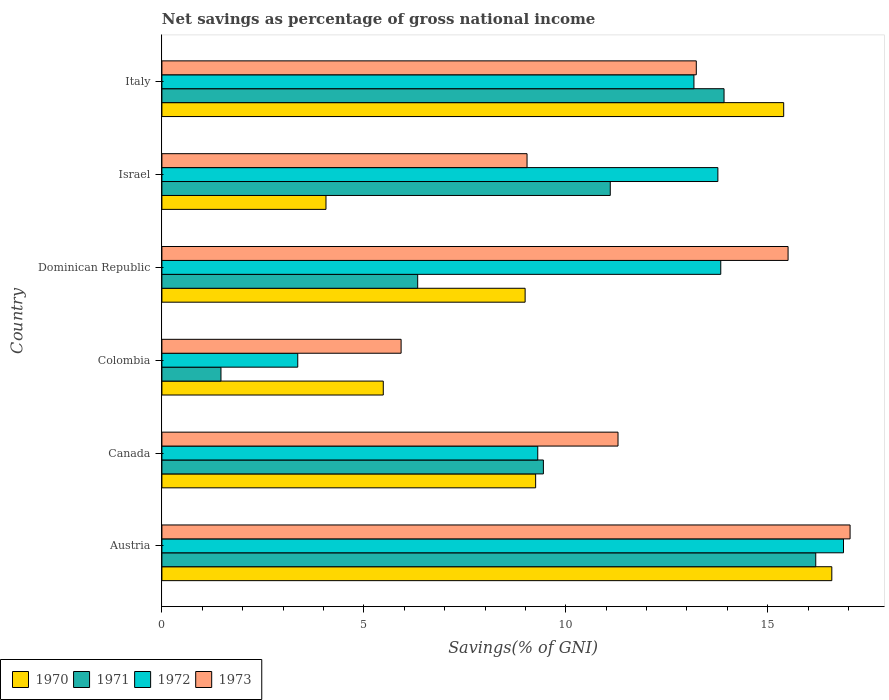Are the number of bars on each tick of the Y-axis equal?
Your response must be concise. Yes. What is the label of the 6th group of bars from the top?
Your response must be concise. Austria. In how many cases, is the number of bars for a given country not equal to the number of legend labels?
Provide a short and direct response. 0. What is the total savings in 1972 in Italy?
Your answer should be compact. 13.17. Across all countries, what is the maximum total savings in 1972?
Your response must be concise. 16.88. Across all countries, what is the minimum total savings in 1972?
Provide a short and direct response. 3.36. In which country was the total savings in 1971 maximum?
Your answer should be very brief. Austria. What is the total total savings in 1971 in the graph?
Provide a short and direct response. 58.45. What is the difference between the total savings in 1971 in Austria and that in Colombia?
Your response must be concise. 14.73. What is the difference between the total savings in 1970 in Austria and the total savings in 1972 in Israel?
Provide a short and direct response. 2.82. What is the average total savings in 1973 per country?
Give a very brief answer. 12.01. What is the difference between the total savings in 1970 and total savings in 1973 in Dominican Republic?
Provide a succinct answer. -6.51. In how many countries, is the total savings in 1970 greater than 7 %?
Your response must be concise. 4. What is the ratio of the total savings in 1973 in Dominican Republic to that in Israel?
Give a very brief answer. 1.71. Is the difference between the total savings in 1970 in Canada and Israel greater than the difference between the total savings in 1973 in Canada and Israel?
Your response must be concise. Yes. What is the difference between the highest and the second highest total savings in 1973?
Make the answer very short. 1.54. What is the difference between the highest and the lowest total savings in 1971?
Keep it short and to the point. 14.73. Is the sum of the total savings in 1970 in Canada and Dominican Republic greater than the maximum total savings in 1971 across all countries?
Your answer should be very brief. Yes. Is it the case that in every country, the sum of the total savings in 1973 and total savings in 1971 is greater than the sum of total savings in 1972 and total savings in 1970?
Your answer should be very brief. No. What does the 2nd bar from the bottom in Italy represents?
Give a very brief answer. 1971. How many bars are there?
Keep it short and to the point. 24. Are all the bars in the graph horizontal?
Provide a short and direct response. Yes. Does the graph contain grids?
Your answer should be very brief. No. Where does the legend appear in the graph?
Ensure brevity in your answer.  Bottom left. How are the legend labels stacked?
Provide a succinct answer. Horizontal. What is the title of the graph?
Your response must be concise. Net savings as percentage of gross national income. What is the label or title of the X-axis?
Keep it short and to the point. Savings(% of GNI). What is the Savings(% of GNI) of 1970 in Austria?
Provide a short and direct response. 16.59. What is the Savings(% of GNI) of 1971 in Austria?
Your answer should be compact. 16.19. What is the Savings(% of GNI) in 1972 in Austria?
Provide a short and direct response. 16.88. What is the Savings(% of GNI) of 1973 in Austria?
Make the answer very short. 17.04. What is the Savings(% of GNI) of 1970 in Canada?
Your response must be concise. 9.25. What is the Savings(% of GNI) in 1971 in Canada?
Give a very brief answer. 9.45. What is the Savings(% of GNI) in 1972 in Canada?
Your answer should be compact. 9.31. What is the Savings(% of GNI) of 1973 in Canada?
Offer a terse response. 11.29. What is the Savings(% of GNI) of 1970 in Colombia?
Your answer should be very brief. 5.48. What is the Savings(% of GNI) in 1971 in Colombia?
Offer a very short reply. 1.46. What is the Savings(% of GNI) of 1972 in Colombia?
Make the answer very short. 3.36. What is the Savings(% of GNI) of 1973 in Colombia?
Your response must be concise. 5.92. What is the Savings(% of GNI) in 1970 in Dominican Republic?
Provide a short and direct response. 8.99. What is the Savings(% of GNI) of 1971 in Dominican Republic?
Give a very brief answer. 6.33. What is the Savings(% of GNI) in 1972 in Dominican Republic?
Keep it short and to the point. 13.84. What is the Savings(% of GNI) in 1973 in Dominican Republic?
Your answer should be compact. 15.5. What is the Savings(% of GNI) of 1970 in Israel?
Keep it short and to the point. 4.06. What is the Savings(% of GNI) of 1971 in Israel?
Provide a short and direct response. 11.1. What is the Savings(% of GNI) in 1972 in Israel?
Offer a terse response. 13.77. What is the Savings(% of GNI) of 1973 in Israel?
Offer a very short reply. 9.04. What is the Savings(% of GNI) of 1970 in Italy?
Your answer should be very brief. 15.4. What is the Savings(% of GNI) of 1971 in Italy?
Make the answer very short. 13.92. What is the Savings(% of GNI) of 1972 in Italy?
Your response must be concise. 13.17. What is the Savings(% of GNI) of 1973 in Italy?
Ensure brevity in your answer.  13.23. Across all countries, what is the maximum Savings(% of GNI) of 1970?
Ensure brevity in your answer.  16.59. Across all countries, what is the maximum Savings(% of GNI) of 1971?
Your answer should be very brief. 16.19. Across all countries, what is the maximum Savings(% of GNI) of 1972?
Provide a succinct answer. 16.88. Across all countries, what is the maximum Savings(% of GNI) of 1973?
Your response must be concise. 17.04. Across all countries, what is the minimum Savings(% of GNI) in 1970?
Ensure brevity in your answer.  4.06. Across all countries, what is the minimum Savings(% of GNI) of 1971?
Keep it short and to the point. 1.46. Across all countries, what is the minimum Savings(% of GNI) of 1972?
Your answer should be very brief. 3.36. Across all countries, what is the minimum Savings(% of GNI) in 1973?
Provide a succinct answer. 5.92. What is the total Savings(% of GNI) in 1970 in the graph?
Offer a very short reply. 59.78. What is the total Savings(% of GNI) of 1971 in the graph?
Make the answer very short. 58.45. What is the total Savings(% of GNI) of 1972 in the graph?
Make the answer very short. 70.32. What is the total Savings(% of GNI) in 1973 in the graph?
Offer a terse response. 72.03. What is the difference between the Savings(% of GNI) in 1970 in Austria and that in Canada?
Make the answer very short. 7.33. What is the difference between the Savings(% of GNI) of 1971 in Austria and that in Canada?
Offer a very short reply. 6.74. What is the difference between the Savings(% of GNI) of 1972 in Austria and that in Canada?
Ensure brevity in your answer.  7.57. What is the difference between the Savings(% of GNI) of 1973 in Austria and that in Canada?
Offer a terse response. 5.75. What is the difference between the Savings(% of GNI) in 1970 in Austria and that in Colombia?
Keep it short and to the point. 11.11. What is the difference between the Savings(% of GNI) in 1971 in Austria and that in Colombia?
Your response must be concise. 14.73. What is the difference between the Savings(% of GNI) in 1972 in Austria and that in Colombia?
Ensure brevity in your answer.  13.51. What is the difference between the Savings(% of GNI) of 1973 in Austria and that in Colombia?
Make the answer very short. 11.12. What is the difference between the Savings(% of GNI) of 1970 in Austria and that in Dominican Republic?
Your answer should be compact. 7.59. What is the difference between the Savings(% of GNI) in 1971 in Austria and that in Dominican Republic?
Provide a short and direct response. 9.86. What is the difference between the Savings(% of GNI) of 1972 in Austria and that in Dominican Republic?
Your answer should be compact. 3.04. What is the difference between the Savings(% of GNI) in 1973 in Austria and that in Dominican Republic?
Provide a short and direct response. 1.54. What is the difference between the Savings(% of GNI) in 1970 in Austria and that in Israel?
Offer a terse response. 12.52. What is the difference between the Savings(% of GNI) in 1971 in Austria and that in Israel?
Your answer should be compact. 5.09. What is the difference between the Savings(% of GNI) of 1972 in Austria and that in Israel?
Your response must be concise. 3.11. What is the difference between the Savings(% of GNI) in 1973 in Austria and that in Israel?
Your answer should be compact. 8. What is the difference between the Savings(% of GNI) of 1970 in Austria and that in Italy?
Give a very brief answer. 1.19. What is the difference between the Savings(% of GNI) of 1971 in Austria and that in Italy?
Your answer should be very brief. 2.27. What is the difference between the Savings(% of GNI) in 1972 in Austria and that in Italy?
Keep it short and to the point. 3.7. What is the difference between the Savings(% of GNI) in 1973 in Austria and that in Italy?
Your response must be concise. 3.81. What is the difference between the Savings(% of GNI) in 1970 in Canada and that in Colombia?
Ensure brevity in your answer.  3.77. What is the difference between the Savings(% of GNI) of 1971 in Canada and that in Colombia?
Offer a very short reply. 7.98. What is the difference between the Savings(% of GNI) in 1972 in Canada and that in Colombia?
Your response must be concise. 5.94. What is the difference between the Savings(% of GNI) of 1973 in Canada and that in Colombia?
Ensure brevity in your answer.  5.37. What is the difference between the Savings(% of GNI) in 1970 in Canada and that in Dominican Republic?
Keep it short and to the point. 0.26. What is the difference between the Savings(% of GNI) in 1971 in Canada and that in Dominican Republic?
Provide a short and direct response. 3.11. What is the difference between the Savings(% of GNI) of 1972 in Canada and that in Dominican Republic?
Provide a succinct answer. -4.53. What is the difference between the Savings(% of GNI) of 1973 in Canada and that in Dominican Republic?
Give a very brief answer. -4.21. What is the difference between the Savings(% of GNI) of 1970 in Canada and that in Israel?
Offer a very short reply. 5.19. What is the difference between the Savings(% of GNI) in 1971 in Canada and that in Israel?
Your answer should be compact. -1.66. What is the difference between the Savings(% of GNI) of 1972 in Canada and that in Israel?
Offer a very short reply. -4.46. What is the difference between the Savings(% of GNI) of 1973 in Canada and that in Israel?
Your answer should be very brief. 2.25. What is the difference between the Savings(% of GNI) in 1970 in Canada and that in Italy?
Your response must be concise. -6.14. What is the difference between the Savings(% of GNI) in 1971 in Canada and that in Italy?
Your response must be concise. -4.47. What is the difference between the Savings(% of GNI) in 1972 in Canada and that in Italy?
Your answer should be very brief. -3.87. What is the difference between the Savings(% of GNI) in 1973 in Canada and that in Italy?
Your response must be concise. -1.94. What is the difference between the Savings(% of GNI) in 1970 in Colombia and that in Dominican Republic?
Make the answer very short. -3.51. What is the difference between the Savings(% of GNI) of 1971 in Colombia and that in Dominican Republic?
Give a very brief answer. -4.87. What is the difference between the Savings(% of GNI) in 1972 in Colombia and that in Dominican Republic?
Keep it short and to the point. -10.47. What is the difference between the Savings(% of GNI) of 1973 in Colombia and that in Dominican Republic?
Your response must be concise. -9.58. What is the difference between the Savings(% of GNI) of 1970 in Colombia and that in Israel?
Provide a short and direct response. 1.42. What is the difference between the Savings(% of GNI) of 1971 in Colombia and that in Israel?
Offer a terse response. -9.64. What is the difference between the Savings(% of GNI) of 1972 in Colombia and that in Israel?
Give a very brief answer. -10.4. What is the difference between the Savings(% of GNI) of 1973 in Colombia and that in Israel?
Give a very brief answer. -3.12. What is the difference between the Savings(% of GNI) in 1970 in Colombia and that in Italy?
Provide a succinct answer. -9.91. What is the difference between the Savings(% of GNI) of 1971 in Colombia and that in Italy?
Your response must be concise. -12.46. What is the difference between the Savings(% of GNI) of 1972 in Colombia and that in Italy?
Offer a very short reply. -9.81. What is the difference between the Savings(% of GNI) of 1973 in Colombia and that in Italy?
Provide a short and direct response. -7.31. What is the difference between the Savings(% of GNI) of 1970 in Dominican Republic and that in Israel?
Provide a succinct answer. 4.93. What is the difference between the Savings(% of GNI) of 1971 in Dominican Republic and that in Israel?
Offer a terse response. -4.77. What is the difference between the Savings(% of GNI) of 1972 in Dominican Republic and that in Israel?
Your response must be concise. 0.07. What is the difference between the Savings(% of GNI) of 1973 in Dominican Republic and that in Israel?
Your response must be concise. 6.46. What is the difference between the Savings(% of GNI) of 1970 in Dominican Republic and that in Italy?
Offer a terse response. -6.4. What is the difference between the Savings(% of GNI) in 1971 in Dominican Republic and that in Italy?
Offer a very short reply. -7.59. What is the difference between the Savings(% of GNI) in 1972 in Dominican Republic and that in Italy?
Your answer should be very brief. 0.66. What is the difference between the Savings(% of GNI) in 1973 in Dominican Republic and that in Italy?
Give a very brief answer. 2.27. What is the difference between the Savings(% of GNI) of 1970 in Israel and that in Italy?
Your answer should be very brief. -11.33. What is the difference between the Savings(% of GNI) in 1971 in Israel and that in Italy?
Offer a terse response. -2.82. What is the difference between the Savings(% of GNI) of 1972 in Israel and that in Italy?
Provide a short and direct response. 0.59. What is the difference between the Savings(% of GNI) of 1973 in Israel and that in Italy?
Provide a short and direct response. -4.19. What is the difference between the Savings(% of GNI) of 1970 in Austria and the Savings(% of GNI) of 1971 in Canada?
Provide a short and direct response. 7.14. What is the difference between the Savings(% of GNI) in 1970 in Austria and the Savings(% of GNI) in 1972 in Canada?
Your answer should be compact. 7.28. What is the difference between the Savings(% of GNI) in 1970 in Austria and the Savings(% of GNI) in 1973 in Canada?
Offer a very short reply. 5.29. What is the difference between the Savings(% of GNI) of 1971 in Austria and the Savings(% of GNI) of 1972 in Canada?
Provide a succinct answer. 6.88. What is the difference between the Savings(% of GNI) of 1971 in Austria and the Savings(% of GNI) of 1973 in Canada?
Your answer should be very brief. 4.9. What is the difference between the Savings(% of GNI) of 1972 in Austria and the Savings(% of GNI) of 1973 in Canada?
Your answer should be compact. 5.58. What is the difference between the Savings(% of GNI) of 1970 in Austria and the Savings(% of GNI) of 1971 in Colombia?
Your answer should be compact. 15.12. What is the difference between the Savings(% of GNI) of 1970 in Austria and the Savings(% of GNI) of 1972 in Colombia?
Your answer should be compact. 13.22. What is the difference between the Savings(% of GNI) of 1970 in Austria and the Savings(% of GNI) of 1973 in Colombia?
Offer a terse response. 10.66. What is the difference between the Savings(% of GNI) of 1971 in Austria and the Savings(% of GNI) of 1972 in Colombia?
Your answer should be compact. 12.83. What is the difference between the Savings(% of GNI) in 1971 in Austria and the Savings(% of GNI) in 1973 in Colombia?
Keep it short and to the point. 10.27. What is the difference between the Savings(% of GNI) of 1972 in Austria and the Savings(% of GNI) of 1973 in Colombia?
Give a very brief answer. 10.95. What is the difference between the Savings(% of GNI) in 1970 in Austria and the Savings(% of GNI) in 1971 in Dominican Republic?
Keep it short and to the point. 10.25. What is the difference between the Savings(% of GNI) of 1970 in Austria and the Savings(% of GNI) of 1972 in Dominican Republic?
Offer a terse response. 2.75. What is the difference between the Savings(% of GNI) in 1970 in Austria and the Savings(% of GNI) in 1973 in Dominican Republic?
Provide a succinct answer. 1.08. What is the difference between the Savings(% of GNI) of 1971 in Austria and the Savings(% of GNI) of 1972 in Dominican Republic?
Your answer should be very brief. 2.35. What is the difference between the Savings(% of GNI) of 1971 in Austria and the Savings(% of GNI) of 1973 in Dominican Republic?
Provide a short and direct response. 0.69. What is the difference between the Savings(% of GNI) of 1972 in Austria and the Savings(% of GNI) of 1973 in Dominican Republic?
Your answer should be very brief. 1.37. What is the difference between the Savings(% of GNI) in 1970 in Austria and the Savings(% of GNI) in 1971 in Israel?
Offer a terse response. 5.49. What is the difference between the Savings(% of GNI) in 1970 in Austria and the Savings(% of GNI) in 1972 in Israel?
Offer a terse response. 2.82. What is the difference between the Savings(% of GNI) in 1970 in Austria and the Savings(% of GNI) in 1973 in Israel?
Your response must be concise. 7.55. What is the difference between the Savings(% of GNI) of 1971 in Austria and the Savings(% of GNI) of 1972 in Israel?
Your answer should be compact. 2.42. What is the difference between the Savings(% of GNI) of 1971 in Austria and the Savings(% of GNI) of 1973 in Israel?
Offer a terse response. 7.15. What is the difference between the Savings(% of GNI) in 1972 in Austria and the Savings(% of GNI) in 1973 in Israel?
Ensure brevity in your answer.  7.84. What is the difference between the Savings(% of GNI) of 1970 in Austria and the Savings(% of GNI) of 1971 in Italy?
Provide a short and direct response. 2.67. What is the difference between the Savings(% of GNI) of 1970 in Austria and the Savings(% of GNI) of 1972 in Italy?
Your answer should be compact. 3.41. What is the difference between the Savings(% of GNI) in 1970 in Austria and the Savings(% of GNI) in 1973 in Italy?
Make the answer very short. 3.36. What is the difference between the Savings(% of GNI) in 1971 in Austria and the Savings(% of GNI) in 1972 in Italy?
Give a very brief answer. 3.02. What is the difference between the Savings(% of GNI) of 1971 in Austria and the Savings(% of GNI) of 1973 in Italy?
Offer a very short reply. 2.96. What is the difference between the Savings(% of GNI) of 1972 in Austria and the Savings(% of GNI) of 1973 in Italy?
Offer a terse response. 3.64. What is the difference between the Savings(% of GNI) of 1970 in Canada and the Savings(% of GNI) of 1971 in Colombia?
Make the answer very short. 7.79. What is the difference between the Savings(% of GNI) of 1970 in Canada and the Savings(% of GNI) of 1972 in Colombia?
Your answer should be compact. 5.89. What is the difference between the Savings(% of GNI) of 1970 in Canada and the Savings(% of GNI) of 1973 in Colombia?
Offer a terse response. 3.33. What is the difference between the Savings(% of GNI) in 1971 in Canada and the Savings(% of GNI) in 1972 in Colombia?
Provide a short and direct response. 6.08. What is the difference between the Savings(% of GNI) in 1971 in Canada and the Savings(% of GNI) in 1973 in Colombia?
Provide a succinct answer. 3.52. What is the difference between the Savings(% of GNI) in 1972 in Canada and the Savings(% of GNI) in 1973 in Colombia?
Provide a short and direct response. 3.38. What is the difference between the Savings(% of GNI) of 1970 in Canada and the Savings(% of GNI) of 1971 in Dominican Republic?
Your response must be concise. 2.92. What is the difference between the Savings(% of GNI) in 1970 in Canada and the Savings(% of GNI) in 1972 in Dominican Republic?
Keep it short and to the point. -4.58. What is the difference between the Savings(% of GNI) in 1970 in Canada and the Savings(% of GNI) in 1973 in Dominican Republic?
Provide a succinct answer. -6.25. What is the difference between the Savings(% of GNI) of 1971 in Canada and the Savings(% of GNI) of 1972 in Dominican Republic?
Ensure brevity in your answer.  -4.39. What is the difference between the Savings(% of GNI) of 1971 in Canada and the Savings(% of GNI) of 1973 in Dominican Republic?
Offer a very short reply. -6.06. What is the difference between the Savings(% of GNI) in 1972 in Canada and the Savings(% of GNI) in 1973 in Dominican Republic?
Offer a very short reply. -6.2. What is the difference between the Savings(% of GNI) in 1970 in Canada and the Savings(% of GNI) in 1971 in Israel?
Ensure brevity in your answer.  -1.85. What is the difference between the Savings(% of GNI) of 1970 in Canada and the Savings(% of GNI) of 1972 in Israel?
Provide a short and direct response. -4.51. What is the difference between the Savings(% of GNI) in 1970 in Canada and the Savings(% of GNI) in 1973 in Israel?
Keep it short and to the point. 0.21. What is the difference between the Savings(% of GNI) of 1971 in Canada and the Savings(% of GNI) of 1972 in Israel?
Offer a terse response. -4.32. What is the difference between the Savings(% of GNI) of 1971 in Canada and the Savings(% of GNI) of 1973 in Israel?
Provide a short and direct response. 0.4. What is the difference between the Savings(% of GNI) in 1972 in Canada and the Savings(% of GNI) in 1973 in Israel?
Make the answer very short. 0.27. What is the difference between the Savings(% of GNI) of 1970 in Canada and the Savings(% of GNI) of 1971 in Italy?
Make the answer very short. -4.66. What is the difference between the Savings(% of GNI) of 1970 in Canada and the Savings(% of GNI) of 1972 in Italy?
Your answer should be compact. -3.92. What is the difference between the Savings(% of GNI) of 1970 in Canada and the Savings(% of GNI) of 1973 in Italy?
Give a very brief answer. -3.98. What is the difference between the Savings(% of GNI) of 1971 in Canada and the Savings(% of GNI) of 1972 in Italy?
Your answer should be compact. -3.73. What is the difference between the Savings(% of GNI) of 1971 in Canada and the Savings(% of GNI) of 1973 in Italy?
Your answer should be very brief. -3.79. What is the difference between the Savings(% of GNI) of 1972 in Canada and the Savings(% of GNI) of 1973 in Italy?
Your answer should be very brief. -3.93. What is the difference between the Savings(% of GNI) in 1970 in Colombia and the Savings(% of GNI) in 1971 in Dominican Republic?
Keep it short and to the point. -0.85. What is the difference between the Savings(% of GNI) of 1970 in Colombia and the Savings(% of GNI) of 1972 in Dominican Republic?
Give a very brief answer. -8.36. What is the difference between the Savings(% of GNI) of 1970 in Colombia and the Savings(% of GNI) of 1973 in Dominican Republic?
Your answer should be very brief. -10.02. What is the difference between the Savings(% of GNI) in 1971 in Colombia and the Savings(% of GNI) in 1972 in Dominican Republic?
Offer a very short reply. -12.38. What is the difference between the Savings(% of GNI) of 1971 in Colombia and the Savings(% of GNI) of 1973 in Dominican Republic?
Offer a terse response. -14.04. What is the difference between the Savings(% of GNI) of 1972 in Colombia and the Savings(% of GNI) of 1973 in Dominican Republic?
Provide a succinct answer. -12.14. What is the difference between the Savings(% of GNI) of 1970 in Colombia and the Savings(% of GNI) of 1971 in Israel?
Your answer should be very brief. -5.62. What is the difference between the Savings(% of GNI) in 1970 in Colombia and the Savings(% of GNI) in 1972 in Israel?
Offer a terse response. -8.28. What is the difference between the Savings(% of GNI) of 1970 in Colombia and the Savings(% of GNI) of 1973 in Israel?
Offer a very short reply. -3.56. What is the difference between the Savings(% of GNI) in 1971 in Colombia and the Savings(% of GNI) in 1972 in Israel?
Your answer should be compact. -12.3. What is the difference between the Savings(% of GNI) of 1971 in Colombia and the Savings(% of GNI) of 1973 in Israel?
Provide a succinct answer. -7.58. What is the difference between the Savings(% of GNI) in 1972 in Colombia and the Savings(% of GNI) in 1973 in Israel?
Offer a very short reply. -5.68. What is the difference between the Savings(% of GNI) in 1970 in Colombia and the Savings(% of GNI) in 1971 in Italy?
Provide a short and direct response. -8.44. What is the difference between the Savings(% of GNI) of 1970 in Colombia and the Savings(% of GNI) of 1972 in Italy?
Your response must be concise. -7.69. What is the difference between the Savings(% of GNI) of 1970 in Colombia and the Savings(% of GNI) of 1973 in Italy?
Offer a very short reply. -7.75. What is the difference between the Savings(% of GNI) of 1971 in Colombia and the Savings(% of GNI) of 1972 in Italy?
Your response must be concise. -11.71. What is the difference between the Savings(% of GNI) in 1971 in Colombia and the Savings(% of GNI) in 1973 in Italy?
Your answer should be compact. -11.77. What is the difference between the Savings(% of GNI) of 1972 in Colombia and the Savings(% of GNI) of 1973 in Italy?
Your answer should be compact. -9.87. What is the difference between the Savings(% of GNI) in 1970 in Dominican Republic and the Savings(% of GNI) in 1971 in Israel?
Your response must be concise. -2.11. What is the difference between the Savings(% of GNI) of 1970 in Dominican Republic and the Savings(% of GNI) of 1972 in Israel?
Keep it short and to the point. -4.77. What is the difference between the Savings(% of GNI) in 1970 in Dominican Republic and the Savings(% of GNI) in 1973 in Israel?
Offer a very short reply. -0.05. What is the difference between the Savings(% of GNI) in 1971 in Dominican Republic and the Savings(% of GNI) in 1972 in Israel?
Your answer should be compact. -7.43. What is the difference between the Savings(% of GNI) in 1971 in Dominican Republic and the Savings(% of GNI) in 1973 in Israel?
Offer a very short reply. -2.71. What is the difference between the Savings(% of GNI) of 1972 in Dominican Republic and the Savings(% of GNI) of 1973 in Israel?
Offer a very short reply. 4.8. What is the difference between the Savings(% of GNI) in 1970 in Dominican Republic and the Savings(% of GNI) in 1971 in Italy?
Provide a succinct answer. -4.93. What is the difference between the Savings(% of GNI) in 1970 in Dominican Republic and the Savings(% of GNI) in 1972 in Italy?
Your answer should be very brief. -4.18. What is the difference between the Savings(% of GNI) in 1970 in Dominican Republic and the Savings(% of GNI) in 1973 in Italy?
Give a very brief answer. -4.24. What is the difference between the Savings(% of GNI) in 1971 in Dominican Republic and the Savings(% of GNI) in 1972 in Italy?
Make the answer very short. -6.84. What is the difference between the Savings(% of GNI) in 1971 in Dominican Republic and the Savings(% of GNI) in 1973 in Italy?
Provide a short and direct response. -6.9. What is the difference between the Savings(% of GNI) of 1972 in Dominican Republic and the Savings(% of GNI) of 1973 in Italy?
Your answer should be compact. 0.61. What is the difference between the Savings(% of GNI) in 1970 in Israel and the Savings(% of GNI) in 1971 in Italy?
Your answer should be compact. -9.86. What is the difference between the Savings(% of GNI) in 1970 in Israel and the Savings(% of GNI) in 1972 in Italy?
Your response must be concise. -9.11. What is the difference between the Savings(% of GNI) in 1970 in Israel and the Savings(% of GNI) in 1973 in Italy?
Your response must be concise. -9.17. What is the difference between the Savings(% of GNI) of 1971 in Israel and the Savings(% of GNI) of 1972 in Italy?
Your response must be concise. -2.07. What is the difference between the Savings(% of GNI) of 1971 in Israel and the Savings(% of GNI) of 1973 in Italy?
Make the answer very short. -2.13. What is the difference between the Savings(% of GNI) of 1972 in Israel and the Savings(% of GNI) of 1973 in Italy?
Make the answer very short. 0.53. What is the average Savings(% of GNI) of 1970 per country?
Provide a short and direct response. 9.96. What is the average Savings(% of GNI) of 1971 per country?
Make the answer very short. 9.74. What is the average Savings(% of GNI) in 1972 per country?
Ensure brevity in your answer.  11.72. What is the average Savings(% of GNI) of 1973 per country?
Provide a succinct answer. 12.01. What is the difference between the Savings(% of GNI) in 1970 and Savings(% of GNI) in 1971 in Austria?
Provide a succinct answer. 0.4. What is the difference between the Savings(% of GNI) of 1970 and Savings(% of GNI) of 1972 in Austria?
Provide a short and direct response. -0.29. What is the difference between the Savings(% of GNI) of 1970 and Savings(% of GNI) of 1973 in Austria?
Keep it short and to the point. -0.45. What is the difference between the Savings(% of GNI) of 1971 and Savings(% of GNI) of 1972 in Austria?
Provide a succinct answer. -0.69. What is the difference between the Savings(% of GNI) in 1971 and Savings(% of GNI) in 1973 in Austria?
Your response must be concise. -0.85. What is the difference between the Savings(% of GNI) of 1972 and Savings(% of GNI) of 1973 in Austria?
Give a very brief answer. -0.16. What is the difference between the Savings(% of GNI) in 1970 and Savings(% of GNI) in 1971 in Canada?
Provide a succinct answer. -0.19. What is the difference between the Savings(% of GNI) of 1970 and Savings(% of GNI) of 1972 in Canada?
Your response must be concise. -0.05. What is the difference between the Savings(% of GNI) in 1970 and Savings(% of GNI) in 1973 in Canada?
Your answer should be compact. -2.04. What is the difference between the Savings(% of GNI) in 1971 and Savings(% of GNI) in 1972 in Canada?
Your answer should be compact. 0.14. What is the difference between the Savings(% of GNI) of 1971 and Savings(% of GNI) of 1973 in Canada?
Ensure brevity in your answer.  -1.85. What is the difference between the Savings(% of GNI) of 1972 and Savings(% of GNI) of 1973 in Canada?
Your response must be concise. -1.99. What is the difference between the Savings(% of GNI) of 1970 and Savings(% of GNI) of 1971 in Colombia?
Keep it short and to the point. 4.02. What is the difference between the Savings(% of GNI) in 1970 and Savings(% of GNI) in 1972 in Colombia?
Your answer should be compact. 2.12. What is the difference between the Savings(% of GNI) in 1970 and Savings(% of GNI) in 1973 in Colombia?
Your answer should be compact. -0.44. What is the difference between the Savings(% of GNI) in 1971 and Savings(% of GNI) in 1972 in Colombia?
Provide a short and direct response. -1.9. What is the difference between the Savings(% of GNI) in 1971 and Savings(% of GNI) in 1973 in Colombia?
Offer a terse response. -4.46. What is the difference between the Savings(% of GNI) in 1972 and Savings(% of GNI) in 1973 in Colombia?
Your answer should be very brief. -2.56. What is the difference between the Savings(% of GNI) in 1970 and Savings(% of GNI) in 1971 in Dominican Republic?
Make the answer very short. 2.66. What is the difference between the Savings(% of GNI) of 1970 and Savings(% of GNI) of 1972 in Dominican Republic?
Make the answer very short. -4.84. What is the difference between the Savings(% of GNI) in 1970 and Savings(% of GNI) in 1973 in Dominican Republic?
Offer a terse response. -6.51. What is the difference between the Savings(% of GNI) of 1971 and Savings(% of GNI) of 1972 in Dominican Republic?
Offer a very short reply. -7.5. What is the difference between the Savings(% of GNI) in 1971 and Savings(% of GNI) in 1973 in Dominican Republic?
Your answer should be compact. -9.17. What is the difference between the Savings(% of GNI) in 1972 and Savings(% of GNI) in 1973 in Dominican Republic?
Ensure brevity in your answer.  -1.67. What is the difference between the Savings(% of GNI) of 1970 and Savings(% of GNI) of 1971 in Israel?
Make the answer very short. -7.04. What is the difference between the Savings(% of GNI) in 1970 and Savings(% of GNI) in 1972 in Israel?
Your response must be concise. -9.7. What is the difference between the Savings(% of GNI) in 1970 and Savings(% of GNI) in 1973 in Israel?
Provide a short and direct response. -4.98. What is the difference between the Savings(% of GNI) in 1971 and Savings(% of GNI) in 1972 in Israel?
Ensure brevity in your answer.  -2.66. What is the difference between the Savings(% of GNI) in 1971 and Savings(% of GNI) in 1973 in Israel?
Keep it short and to the point. 2.06. What is the difference between the Savings(% of GNI) of 1972 and Savings(% of GNI) of 1973 in Israel?
Offer a very short reply. 4.73. What is the difference between the Savings(% of GNI) in 1970 and Savings(% of GNI) in 1971 in Italy?
Your response must be concise. 1.48. What is the difference between the Savings(% of GNI) of 1970 and Savings(% of GNI) of 1972 in Italy?
Offer a terse response. 2.22. What is the difference between the Savings(% of GNI) of 1970 and Savings(% of GNI) of 1973 in Italy?
Make the answer very short. 2.16. What is the difference between the Savings(% of GNI) in 1971 and Savings(% of GNI) in 1972 in Italy?
Offer a very short reply. 0.75. What is the difference between the Savings(% of GNI) of 1971 and Savings(% of GNI) of 1973 in Italy?
Offer a terse response. 0.69. What is the difference between the Savings(% of GNI) of 1972 and Savings(% of GNI) of 1973 in Italy?
Ensure brevity in your answer.  -0.06. What is the ratio of the Savings(% of GNI) of 1970 in Austria to that in Canada?
Keep it short and to the point. 1.79. What is the ratio of the Savings(% of GNI) of 1971 in Austria to that in Canada?
Provide a succinct answer. 1.71. What is the ratio of the Savings(% of GNI) in 1972 in Austria to that in Canada?
Your answer should be very brief. 1.81. What is the ratio of the Savings(% of GNI) of 1973 in Austria to that in Canada?
Provide a succinct answer. 1.51. What is the ratio of the Savings(% of GNI) of 1970 in Austria to that in Colombia?
Your response must be concise. 3.03. What is the ratio of the Savings(% of GNI) of 1971 in Austria to that in Colombia?
Your answer should be very brief. 11.07. What is the ratio of the Savings(% of GNI) in 1972 in Austria to that in Colombia?
Provide a succinct answer. 5.02. What is the ratio of the Savings(% of GNI) in 1973 in Austria to that in Colombia?
Ensure brevity in your answer.  2.88. What is the ratio of the Savings(% of GNI) in 1970 in Austria to that in Dominican Republic?
Your answer should be compact. 1.84. What is the ratio of the Savings(% of GNI) in 1971 in Austria to that in Dominican Republic?
Make the answer very short. 2.56. What is the ratio of the Savings(% of GNI) of 1972 in Austria to that in Dominican Republic?
Offer a very short reply. 1.22. What is the ratio of the Savings(% of GNI) in 1973 in Austria to that in Dominican Republic?
Make the answer very short. 1.1. What is the ratio of the Savings(% of GNI) in 1970 in Austria to that in Israel?
Provide a succinct answer. 4.08. What is the ratio of the Savings(% of GNI) in 1971 in Austria to that in Israel?
Your answer should be very brief. 1.46. What is the ratio of the Savings(% of GNI) in 1972 in Austria to that in Israel?
Your answer should be very brief. 1.23. What is the ratio of the Savings(% of GNI) of 1973 in Austria to that in Israel?
Give a very brief answer. 1.88. What is the ratio of the Savings(% of GNI) of 1970 in Austria to that in Italy?
Provide a short and direct response. 1.08. What is the ratio of the Savings(% of GNI) of 1971 in Austria to that in Italy?
Your answer should be compact. 1.16. What is the ratio of the Savings(% of GNI) in 1972 in Austria to that in Italy?
Keep it short and to the point. 1.28. What is the ratio of the Savings(% of GNI) of 1973 in Austria to that in Italy?
Make the answer very short. 1.29. What is the ratio of the Savings(% of GNI) of 1970 in Canada to that in Colombia?
Give a very brief answer. 1.69. What is the ratio of the Savings(% of GNI) of 1971 in Canada to that in Colombia?
Your response must be concise. 6.46. What is the ratio of the Savings(% of GNI) in 1972 in Canada to that in Colombia?
Keep it short and to the point. 2.77. What is the ratio of the Savings(% of GNI) in 1973 in Canada to that in Colombia?
Your answer should be very brief. 1.91. What is the ratio of the Savings(% of GNI) of 1970 in Canada to that in Dominican Republic?
Make the answer very short. 1.03. What is the ratio of the Savings(% of GNI) in 1971 in Canada to that in Dominican Republic?
Make the answer very short. 1.49. What is the ratio of the Savings(% of GNI) of 1972 in Canada to that in Dominican Republic?
Make the answer very short. 0.67. What is the ratio of the Savings(% of GNI) in 1973 in Canada to that in Dominican Republic?
Keep it short and to the point. 0.73. What is the ratio of the Savings(% of GNI) of 1970 in Canada to that in Israel?
Make the answer very short. 2.28. What is the ratio of the Savings(% of GNI) of 1971 in Canada to that in Israel?
Provide a succinct answer. 0.85. What is the ratio of the Savings(% of GNI) in 1972 in Canada to that in Israel?
Offer a very short reply. 0.68. What is the ratio of the Savings(% of GNI) of 1973 in Canada to that in Israel?
Your answer should be compact. 1.25. What is the ratio of the Savings(% of GNI) of 1970 in Canada to that in Italy?
Ensure brevity in your answer.  0.6. What is the ratio of the Savings(% of GNI) in 1971 in Canada to that in Italy?
Make the answer very short. 0.68. What is the ratio of the Savings(% of GNI) in 1972 in Canada to that in Italy?
Provide a short and direct response. 0.71. What is the ratio of the Savings(% of GNI) of 1973 in Canada to that in Italy?
Offer a terse response. 0.85. What is the ratio of the Savings(% of GNI) in 1970 in Colombia to that in Dominican Republic?
Your answer should be compact. 0.61. What is the ratio of the Savings(% of GNI) of 1971 in Colombia to that in Dominican Republic?
Provide a succinct answer. 0.23. What is the ratio of the Savings(% of GNI) in 1972 in Colombia to that in Dominican Republic?
Ensure brevity in your answer.  0.24. What is the ratio of the Savings(% of GNI) in 1973 in Colombia to that in Dominican Republic?
Make the answer very short. 0.38. What is the ratio of the Savings(% of GNI) of 1970 in Colombia to that in Israel?
Your response must be concise. 1.35. What is the ratio of the Savings(% of GNI) in 1971 in Colombia to that in Israel?
Keep it short and to the point. 0.13. What is the ratio of the Savings(% of GNI) of 1972 in Colombia to that in Israel?
Provide a succinct answer. 0.24. What is the ratio of the Savings(% of GNI) of 1973 in Colombia to that in Israel?
Keep it short and to the point. 0.66. What is the ratio of the Savings(% of GNI) of 1970 in Colombia to that in Italy?
Offer a very short reply. 0.36. What is the ratio of the Savings(% of GNI) in 1971 in Colombia to that in Italy?
Your answer should be compact. 0.11. What is the ratio of the Savings(% of GNI) in 1972 in Colombia to that in Italy?
Your response must be concise. 0.26. What is the ratio of the Savings(% of GNI) of 1973 in Colombia to that in Italy?
Provide a succinct answer. 0.45. What is the ratio of the Savings(% of GNI) in 1970 in Dominican Republic to that in Israel?
Your answer should be compact. 2.21. What is the ratio of the Savings(% of GNI) in 1971 in Dominican Republic to that in Israel?
Give a very brief answer. 0.57. What is the ratio of the Savings(% of GNI) of 1973 in Dominican Republic to that in Israel?
Offer a very short reply. 1.71. What is the ratio of the Savings(% of GNI) of 1970 in Dominican Republic to that in Italy?
Offer a very short reply. 0.58. What is the ratio of the Savings(% of GNI) of 1971 in Dominican Republic to that in Italy?
Your response must be concise. 0.46. What is the ratio of the Savings(% of GNI) of 1972 in Dominican Republic to that in Italy?
Offer a very short reply. 1.05. What is the ratio of the Savings(% of GNI) of 1973 in Dominican Republic to that in Italy?
Your answer should be very brief. 1.17. What is the ratio of the Savings(% of GNI) in 1970 in Israel to that in Italy?
Ensure brevity in your answer.  0.26. What is the ratio of the Savings(% of GNI) of 1971 in Israel to that in Italy?
Your answer should be compact. 0.8. What is the ratio of the Savings(% of GNI) in 1972 in Israel to that in Italy?
Your answer should be compact. 1.04. What is the ratio of the Savings(% of GNI) of 1973 in Israel to that in Italy?
Offer a very short reply. 0.68. What is the difference between the highest and the second highest Savings(% of GNI) in 1970?
Make the answer very short. 1.19. What is the difference between the highest and the second highest Savings(% of GNI) of 1971?
Your answer should be very brief. 2.27. What is the difference between the highest and the second highest Savings(% of GNI) in 1972?
Your answer should be very brief. 3.04. What is the difference between the highest and the second highest Savings(% of GNI) in 1973?
Provide a short and direct response. 1.54. What is the difference between the highest and the lowest Savings(% of GNI) of 1970?
Your answer should be compact. 12.52. What is the difference between the highest and the lowest Savings(% of GNI) in 1971?
Offer a very short reply. 14.73. What is the difference between the highest and the lowest Savings(% of GNI) in 1972?
Make the answer very short. 13.51. What is the difference between the highest and the lowest Savings(% of GNI) in 1973?
Give a very brief answer. 11.12. 